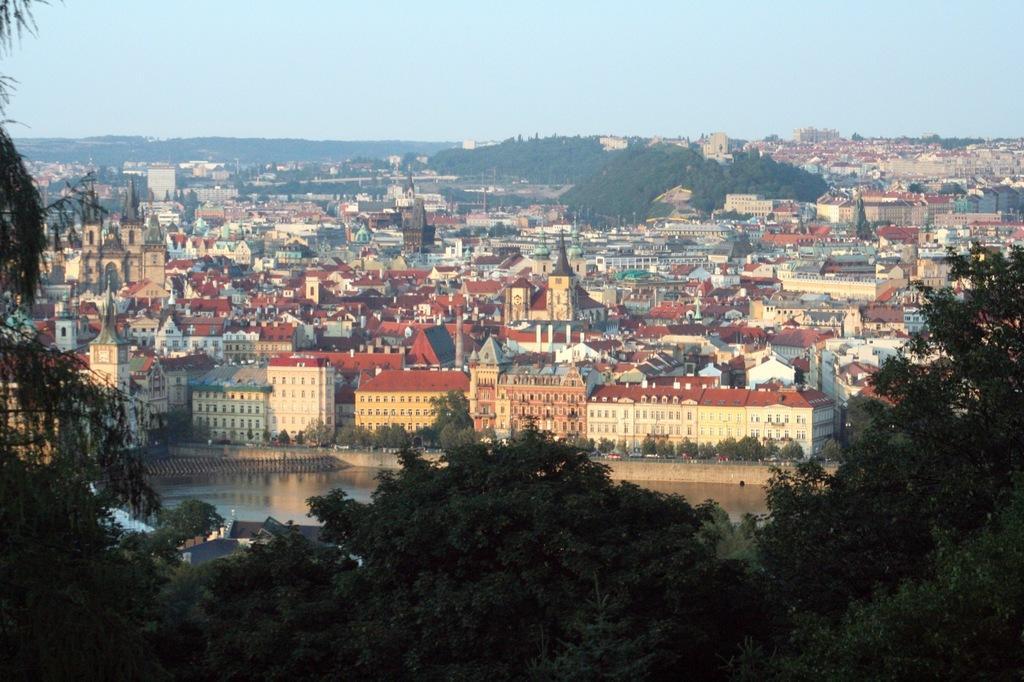Can you describe this image briefly? In this picture I can see many buildings and trees. At the bottom I can see many cars which are running on the road, beside that I can see the street lights. At the top I can see the sky. 